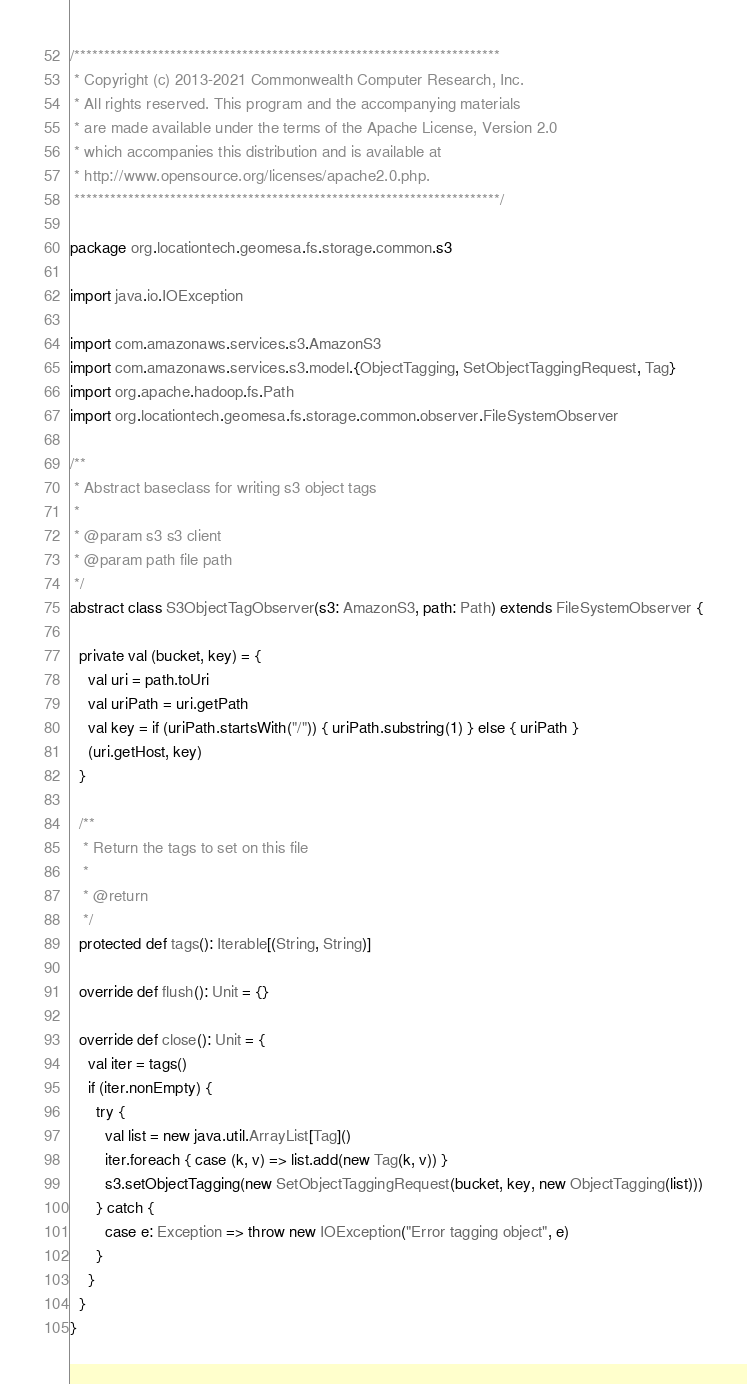<code> <loc_0><loc_0><loc_500><loc_500><_Scala_>/***********************************************************************
 * Copyright (c) 2013-2021 Commonwealth Computer Research, Inc.
 * All rights reserved. This program and the accompanying materials
 * are made available under the terms of the Apache License, Version 2.0
 * which accompanies this distribution and is available at
 * http://www.opensource.org/licenses/apache2.0.php.
 ***********************************************************************/

package org.locationtech.geomesa.fs.storage.common.s3

import java.io.IOException

import com.amazonaws.services.s3.AmazonS3
import com.amazonaws.services.s3.model.{ObjectTagging, SetObjectTaggingRequest, Tag}
import org.apache.hadoop.fs.Path
import org.locationtech.geomesa.fs.storage.common.observer.FileSystemObserver

/**
 * Abstract baseclass for writing s3 object tags
 *
 * @param s3 s3 client
 * @param path file path
 */
abstract class S3ObjectTagObserver(s3: AmazonS3, path: Path) extends FileSystemObserver {

  private val (bucket, key) = {
    val uri = path.toUri
    val uriPath = uri.getPath
    val key = if (uriPath.startsWith("/")) { uriPath.substring(1) } else { uriPath }
    (uri.getHost, key)
  }

  /**
   * Return the tags to set on this file
   *
   * @return
   */
  protected def tags(): Iterable[(String, String)]

  override def flush(): Unit = {}

  override def close(): Unit = {
    val iter = tags()
    if (iter.nonEmpty) {
      try {
        val list = new java.util.ArrayList[Tag]()
        iter.foreach { case (k, v) => list.add(new Tag(k, v)) }
        s3.setObjectTagging(new SetObjectTaggingRequest(bucket, key, new ObjectTagging(list)))
      } catch {
        case e: Exception => throw new IOException("Error tagging object", e)
      }
    }
  }
}
</code> 